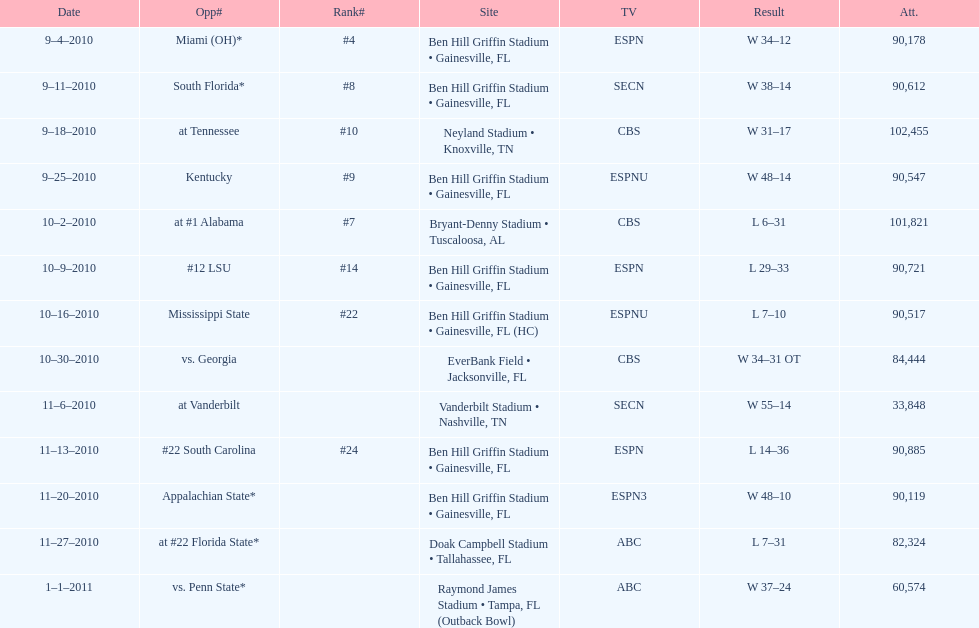How many games were played at the ben hill griffin stadium during the 2010-2011 season? 7. Parse the full table. {'header': ['Date', 'Opp#', 'Rank#', 'Site', 'TV', 'Result', 'Att.'], 'rows': [['9–4–2010', 'Miami (OH)*', '#4', 'Ben Hill Griffin Stadium • Gainesville, FL', 'ESPN', 'W\xa034–12', '90,178'], ['9–11–2010', 'South Florida*', '#8', 'Ben Hill Griffin Stadium • Gainesville, FL', 'SECN', 'W\xa038–14', '90,612'], ['9–18–2010', 'at\xa0Tennessee', '#10', 'Neyland Stadium • Knoxville, TN', 'CBS', 'W\xa031–17', '102,455'], ['9–25–2010', 'Kentucky', '#9', 'Ben Hill Griffin Stadium • Gainesville, FL', 'ESPNU', 'W\xa048–14', '90,547'], ['10–2–2010', 'at\xa0#1\xa0Alabama', '#7', 'Bryant-Denny Stadium • Tuscaloosa, AL', 'CBS', 'L\xa06–31', '101,821'], ['10–9–2010', '#12\xa0LSU', '#14', 'Ben Hill Griffin Stadium • Gainesville, FL', 'ESPN', 'L\xa029–33', '90,721'], ['10–16–2010', 'Mississippi State', '#22', 'Ben Hill Griffin Stadium • Gainesville, FL (HC)', 'ESPNU', 'L\xa07–10', '90,517'], ['10–30–2010', 'vs.\xa0Georgia', '', 'EverBank Field • Jacksonville, FL', 'CBS', 'W\xa034–31\xa0OT', '84,444'], ['11–6–2010', 'at\xa0Vanderbilt', '', 'Vanderbilt Stadium • Nashville, TN', 'SECN', 'W\xa055–14', '33,848'], ['11–13–2010', '#22\xa0South Carolina', '#24', 'Ben Hill Griffin Stadium • Gainesville, FL', 'ESPN', 'L\xa014–36', '90,885'], ['11–20–2010', 'Appalachian State*', '', 'Ben Hill Griffin Stadium • Gainesville, FL', 'ESPN3', 'W\xa048–10', '90,119'], ['11–27–2010', 'at\xa0#22\xa0Florida State*', '', 'Doak Campbell Stadium • Tallahassee, FL', 'ABC', 'L\xa07–31', '82,324'], ['1–1–2011', 'vs.\xa0Penn State*', '', 'Raymond James Stadium • Tampa, FL (Outback Bowl)', 'ABC', 'W\xa037–24', '60,574']]} 